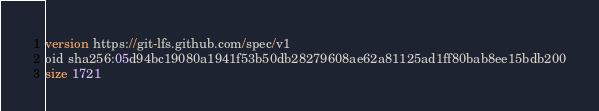<code> <loc_0><loc_0><loc_500><loc_500><_SQL_>version https://git-lfs.github.com/spec/v1
oid sha256:05d94bc19080a1941f53b50db28279608ae62a81125ad1ff80bab8ee15bdb200
size 1721
</code> 